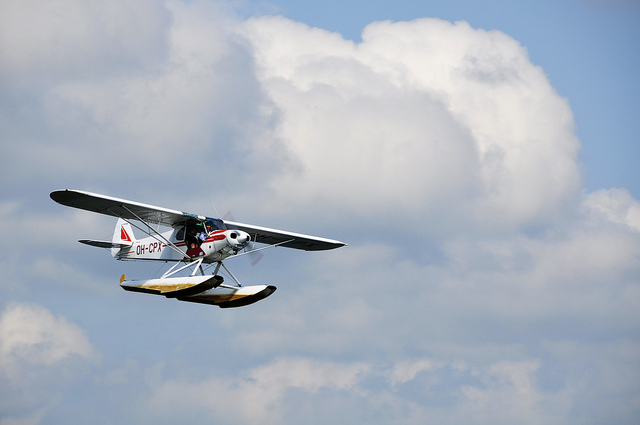Read all the text in this image. CH CPX 